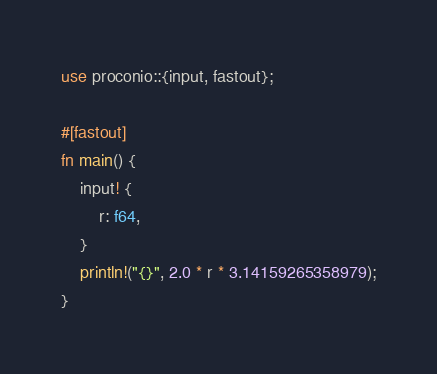<code> <loc_0><loc_0><loc_500><loc_500><_Rust_>use proconio::{input, fastout};

#[fastout]
fn main() {
    input! {
        r: f64,
    }
    println!("{}", 2.0 * r * 3.14159265358979);
}
</code> 